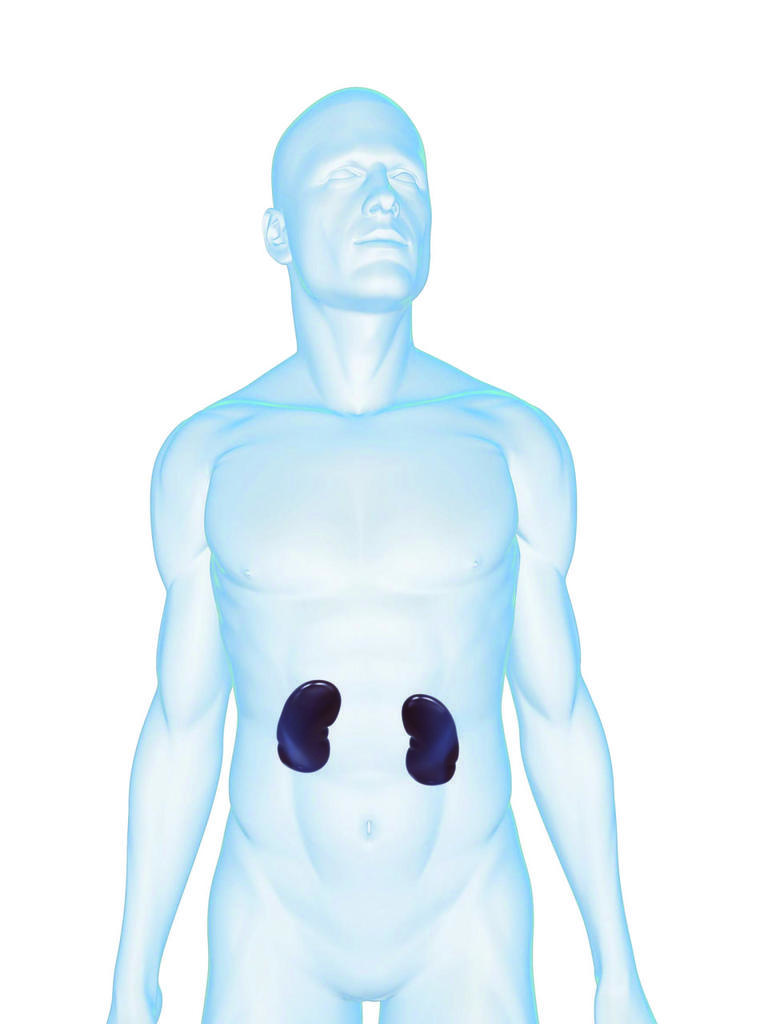Can you describe this image briefly? In the center of the image there is a depiction of a person. 